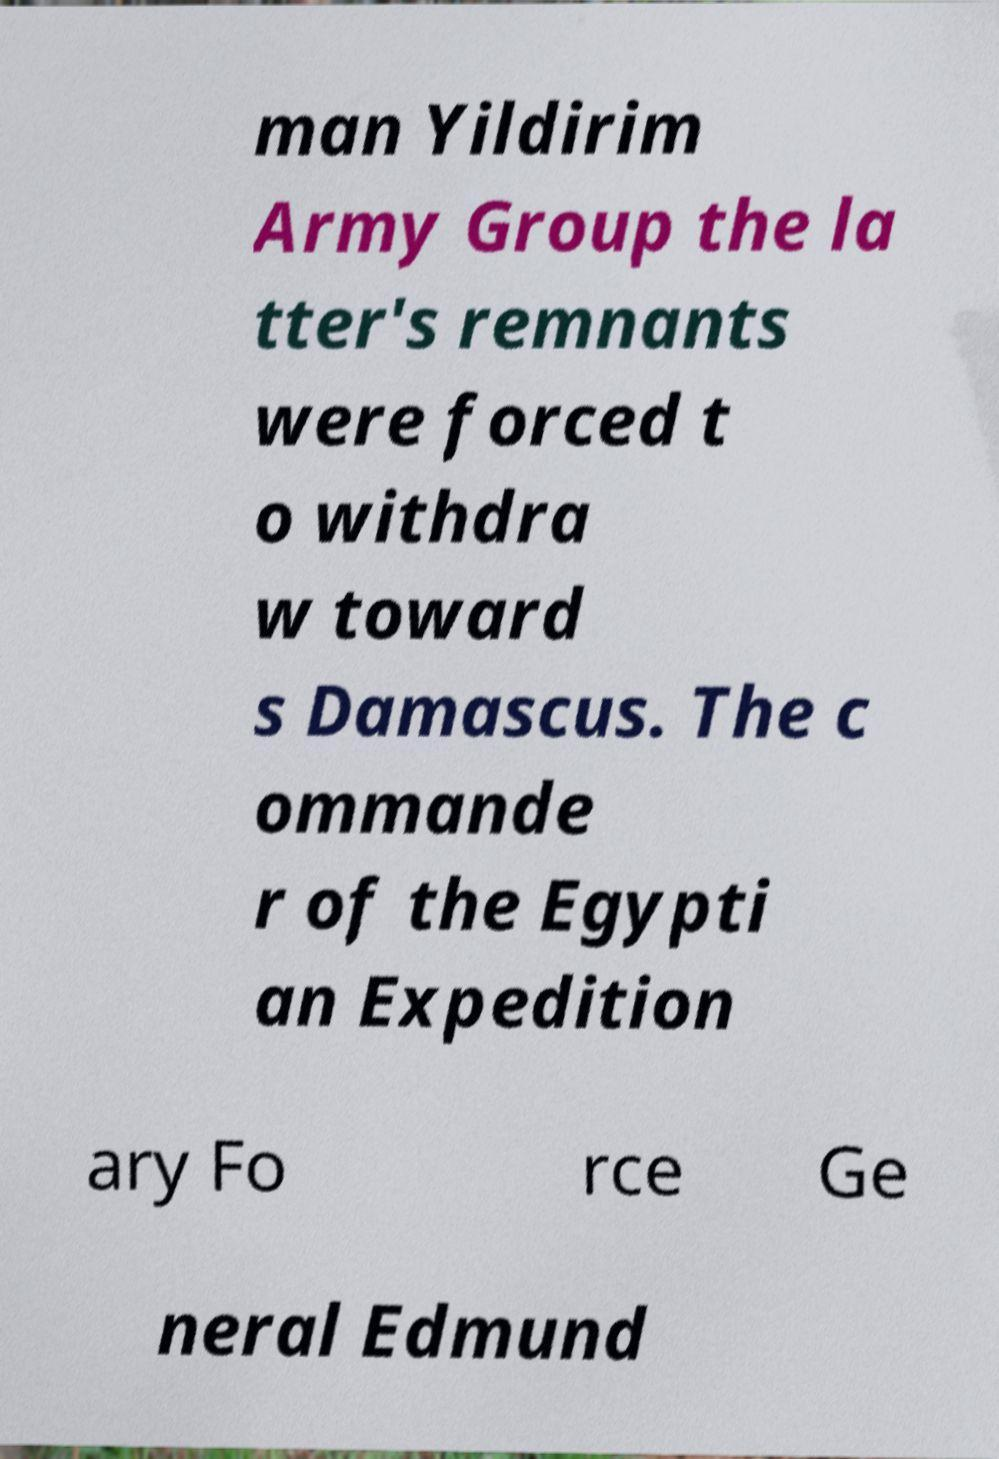Could you assist in decoding the text presented in this image and type it out clearly? man Yildirim Army Group the la tter's remnants were forced t o withdra w toward s Damascus. The c ommande r of the Egypti an Expedition ary Fo rce Ge neral Edmund 